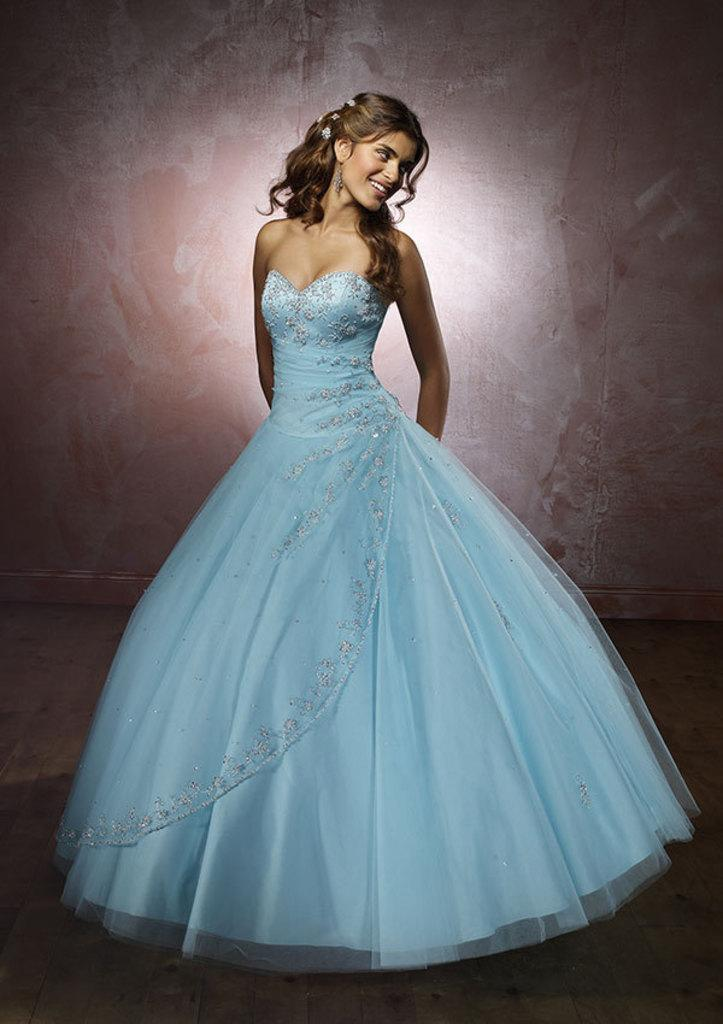Who is the main subject in the image? There is a woman in the image. What is the woman doing in the image? The woman is standing. What is the woman wearing in the image? The woman is wearing a dress. What color is the background of the image? The background of the image is pink. What type of steel is used to construct the game board in the image? There is no game board or steel present in the image; it features a woman standing in front of a pink background. 